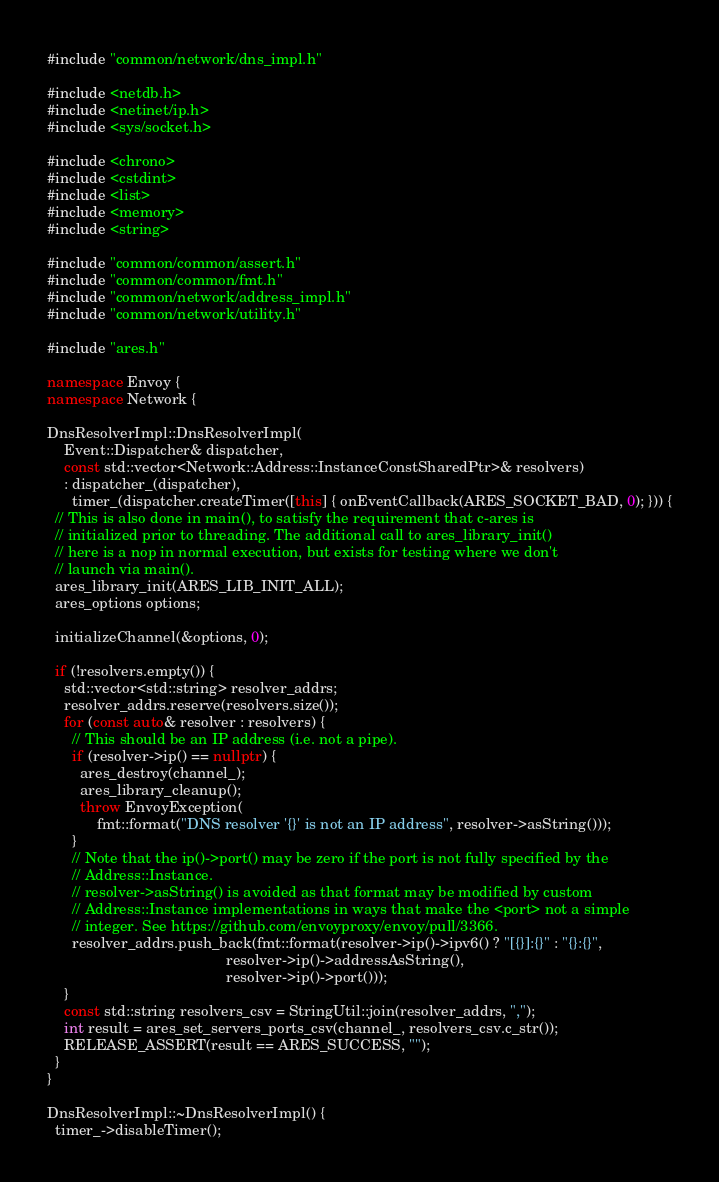Convert code to text. <code><loc_0><loc_0><loc_500><loc_500><_C++_>#include "common/network/dns_impl.h"

#include <netdb.h>
#include <netinet/ip.h>
#include <sys/socket.h>

#include <chrono>
#include <cstdint>
#include <list>
#include <memory>
#include <string>

#include "common/common/assert.h"
#include "common/common/fmt.h"
#include "common/network/address_impl.h"
#include "common/network/utility.h"

#include "ares.h"

namespace Envoy {
namespace Network {

DnsResolverImpl::DnsResolverImpl(
    Event::Dispatcher& dispatcher,
    const std::vector<Network::Address::InstanceConstSharedPtr>& resolvers)
    : dispatcher_(dispatcher),
      timer_(dispatcher.createTimer([this] { onEventCallback(ARES_SOCKET_BAD, 0); })) {
  // This is also done in main(), to satisfy the requirement that c-ares is
  // initialized prior to threading. The additional call to ares_library_init()
  // here is a nop in normal execution, but exists for testing where we don't
  // launch via main().
  ares_library_init(ARES_LIB_INIT_ALL);
  ares_options options;

  initializeChannel(&options, 0);

  if (!resolvers.empty()) {
    std::vector<std::string> resolver_addrs;
    resolver_addrs.reserve(resolvers.size());
    for (const auto& resolver : resolvers) {
      // This should be an IP address (i.e. not a pipe).
      if (resolver->ip() == nullptr) {
        ares_destroy(channel_);
        ares_library_cleanup();
        throw EnvoyException(
            fmt::format("DNS resolver '{}' is not an IP address", resolver->asString()));
      }
      // Note that the ip()->port() may be zero if the port is not fully specified by the
      // Address::Instance.
      // resolver->asString() is avoided as that format may be modified by custom
      // Address::Instance implementations in ways that make the <port> not a simple
      // integer. See https://github.com/envoyproxy/envoy/pull/3366.
      resolver_addrs.push_back(fmt::format(resolver->ip()->ipv6() ? "[{}]:{}" : "{}:{}",
                                           resolver->ip()->addressAsString(),
                                           resolver->ip()->port()));
    }
    const std::string resolvers_csv = StringUtil::join(resolver_addrs, ",");
    int result = ares_set_servers_ports_csv(channel_, resolvers_csv.c_str());
    RELEASE_ASSERT(result == ARES_SUCCESS, "");
  }
}

DnsResolverImpl::~DnsResolverImpl() {
  timer_->disableTimer();</code> 